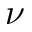<formula> <loc_0><loc_0><loc_500><loc_500>\nu</formula> 